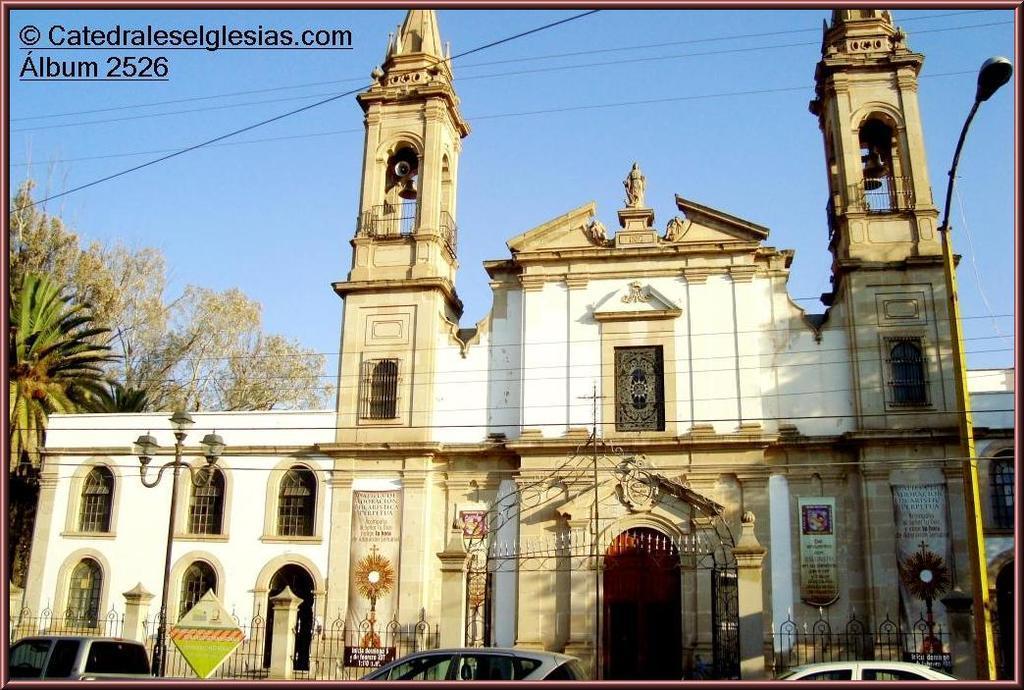Can you describe this image briefly? In this image we can see a building with windows and door. On top of the building there are bells. And there is a statue. In front of the building there are vehicles, railings and light poles. On the left side there are trees. In the background there is sky. On the building there are banners. In the top left corner there is something written. 